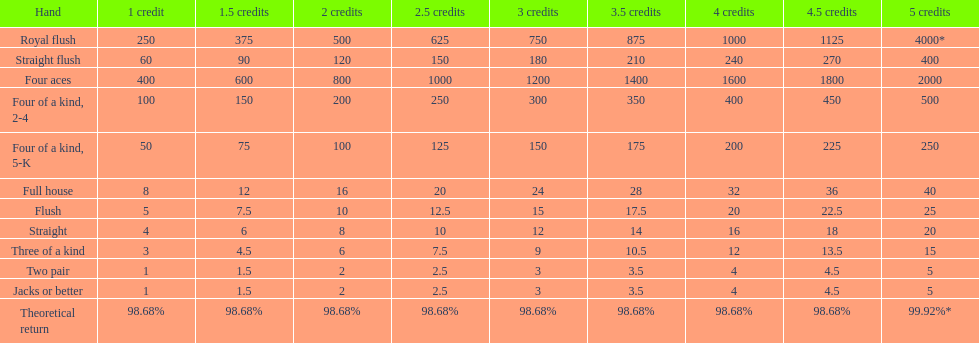What's the best type of four of a kind to win? Four of a kind, 2-4. 